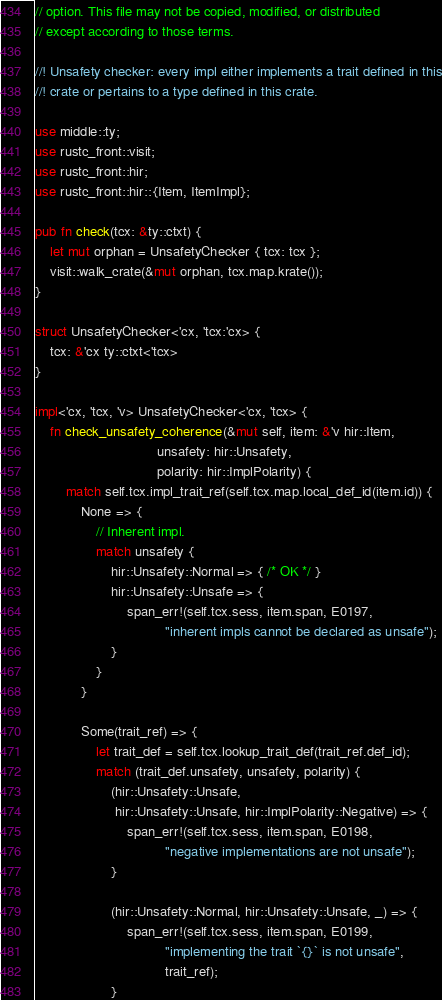<code> <loc_0><loc_0><loc_500><loc_500><_Rust_>// option. This file may not be copied, modified, or distributed
// except according to those terms.

//! Unsafety checker: every impl either implements a trait defined in this
//! crate or pertains to a type defined in this crate.

use middle::ty;
use rustc_front::visit;
use rustc_front::hir;
use rustc_front::hir::{Item, ItemImpl};

pub fn check(tcx: &ty::ctxt) {
    let mut orphan = UnsafetyChecker { tcx: tcx };
    visit::walk_crate(&mut orphan, tcx.map.krate());
}

struct UnsafetyChecker<'cx, 'tcx:'cx> {
    tcx: &'cx ty::ctxt<'tcx>
}

impl<'cx, 'tcx, 'v> UnsafetyChecker<'cx, 'tcx> {
    fn check_unsafety_coherence(&mut self, item: &'v hir::Item,
                                unsafety: hir::Unsafety,
                                polarity: hir::ImplPolarity) {
        match self.tcx.impl_trait_ref(self.tcx.map.local_def_id(item.id)) {
            None => {
                // Inherent impl.
                match unsafety {
                    hir::Unsafety::Normal => { /* OK */ }
                    hir::Unsafety::Unsafe => {
                        span_err!(self.tcx.sess, item.span, E0197,
                                  "inherent impls cannot be declared as unsafe");
                    }
                }
            }

            Some(trait_ref) => {
                let trait_def = self.tcx.lookup_trait_def(trait_ref.def_id);
                match (trait_def.unsafety, unsafety, polarity) {
                    (hir::Unsafety::Unsafe,
                     hir::Unsafety::Unsafe, hir::ImplPolarity::Negative) => {
                        span_err!(self.tcx.sess, item.span, E0198,
                                  "negative implementations are not unsafe");
                    }

                    (hir::Unsafety::Normal, hir::Unsafety::Unsafe, _) => {
                        span_err!(self.tcx.sess, item.span, E0199,
                                  "implementing the trait `{}` is not unsafe",
                                  trait_ref);
                    }
</code> 